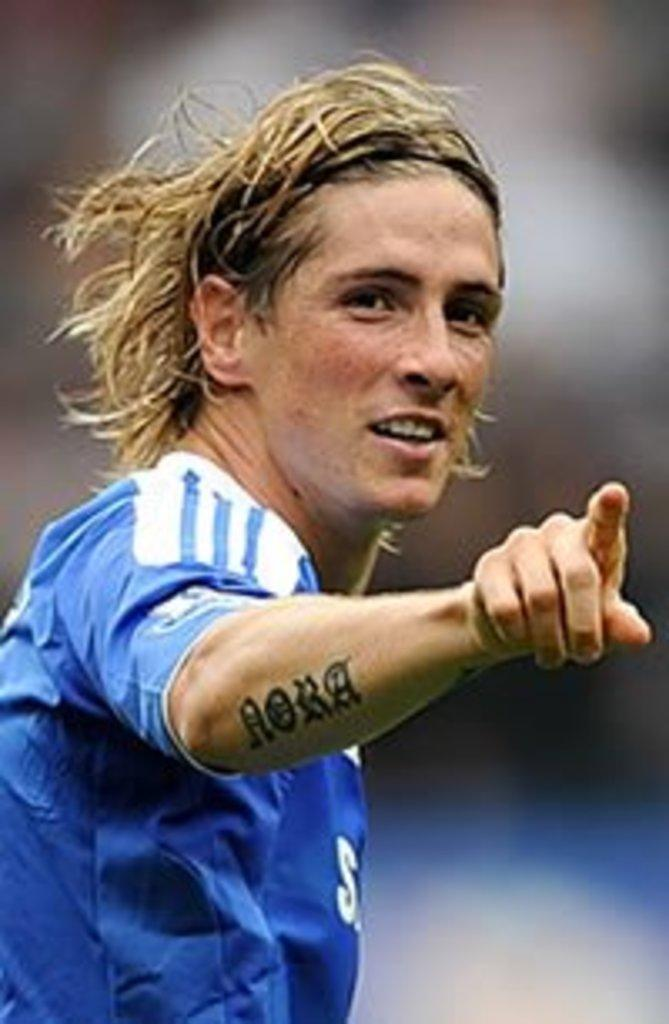What is the main subject of the image? There is a person in the image. What is the person wearing? The person is wearing a blue and white t-shirt. Can you describe the background of the image? The background of the image is blurry. What type of wind can be seen in the image? There is no wind visible in the image; it is a person wearing a blue and white t-shirt with a blurry background. 